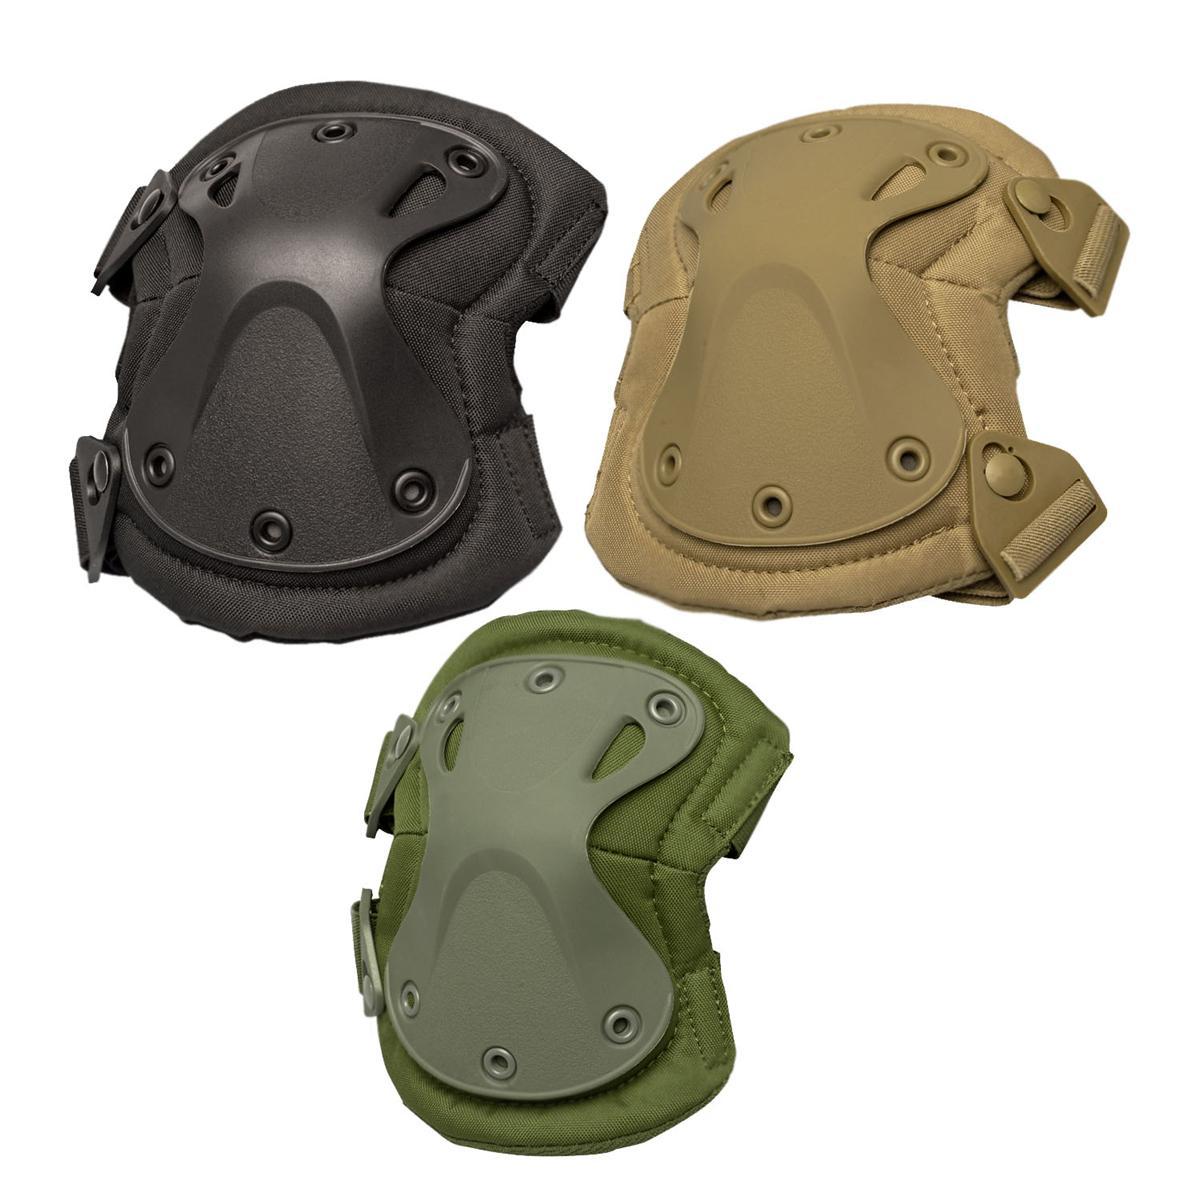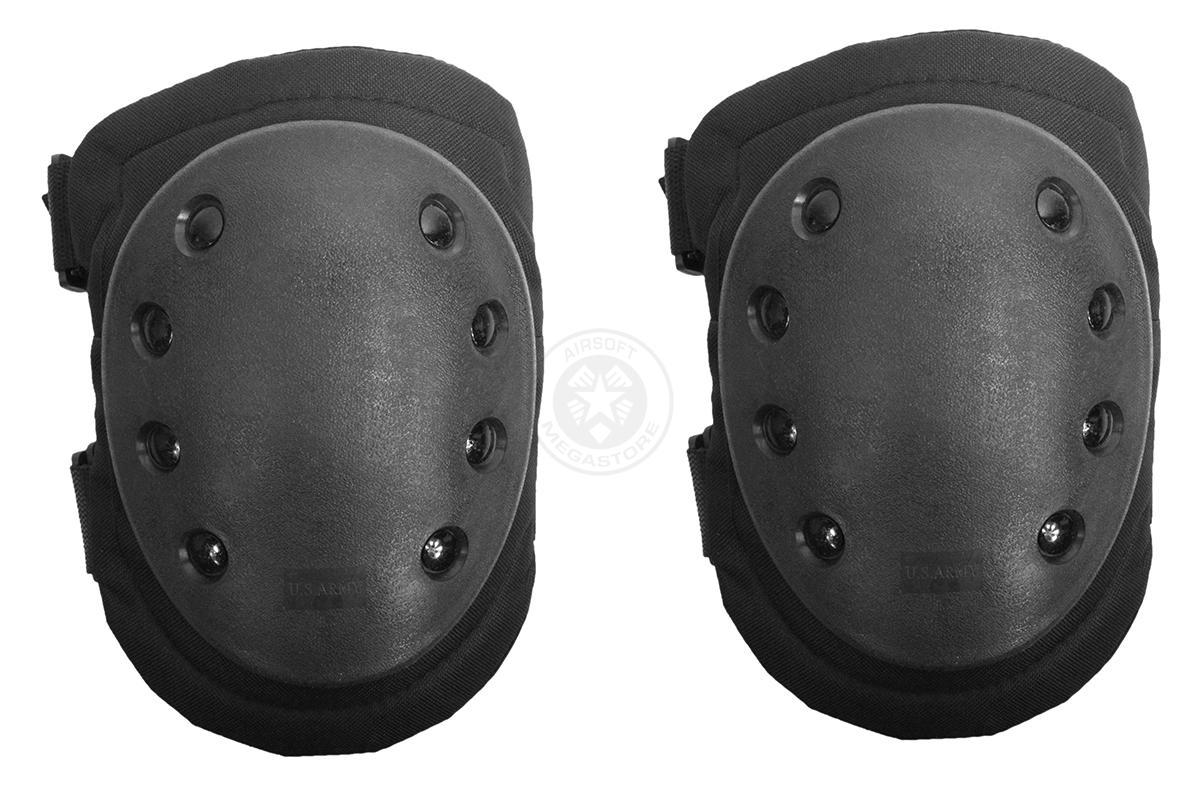The first image is the image on the left, the second image is the image on the right. Evaluate the accuracy of this statement regarding the images: "Both images show knee pads worn over denim jeans.". Is it true? Answer yes or no. No. The first image is the image on the left, the second image is the image on the right. Examine the images to the left and right. Is the description "Two sets of kneepads are shown as they fit on legs over jeans." accurate? Answer yes or no. No. 